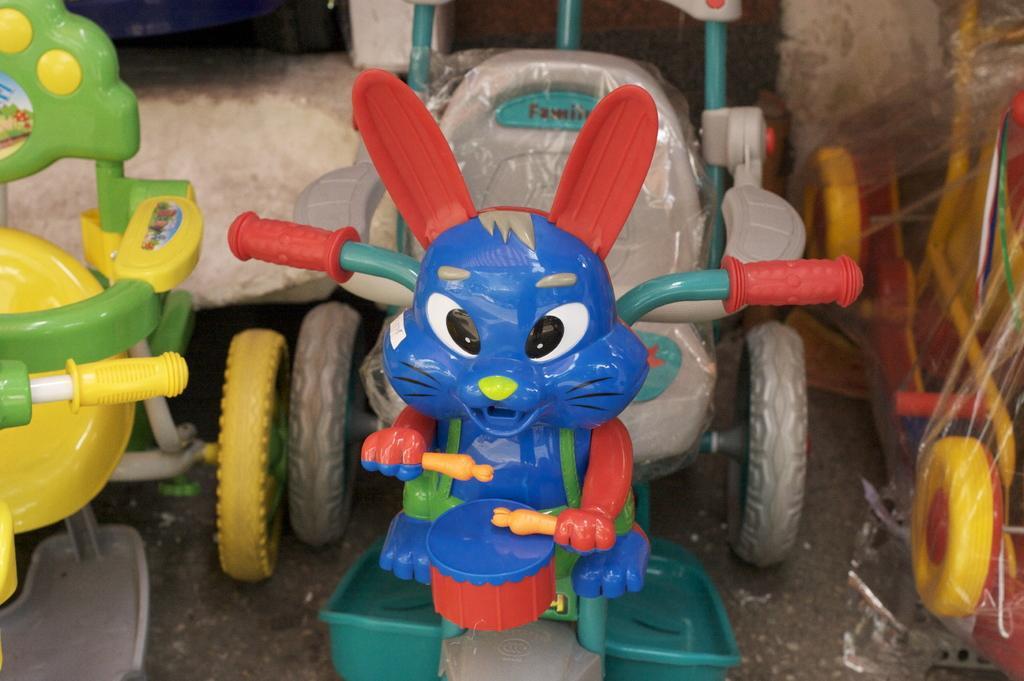Please provide a concise description of this image. In this image I can see a toy bicycle which is blue, grey, green and red in color on the ground and I can see few other bicycles beside it which are yellow, green and red in color. 